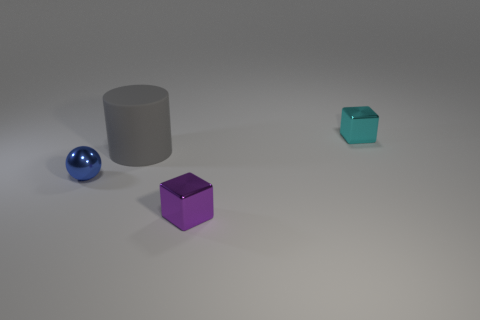How many things are things to the left of the tiny purple shiny object or tiny cubes that are in front of the tiny cyan metallic thing?
Provide a short and direct response. 3. Are there the same number of big objects in front of the big gray cylinder and small blue objects that are in front of the small blue sphere?
Give a very brief answer. Yes. There is a block that is to the left of the tiny cyan shiny block; what is its color?
Give a very brief answer. Purple. Does the shiny sphere have the same color as the shiny block that is in front of the tiny cyan metal object?
Your answer should be compact. No. Are there fewer big red blocks than blue metal balls?
Ensure brevity in your answer.  Yes. There is a small block that is to the right of the purple shiny object; is it the same color as the large matte cylinder?
Your response must be concise. No. What number of blue metallic spheres are the same size as the cyan block?
Your answer should be compact. 1. Is there another large cylinder of the same color as the big rubber cylinder?
Your answer should be very brief. No. Are the tiny blue object and the cylinder made of the same material?
Provide a short and direct response. No. What number of tiny blue objects have the same shape as the small cyan metallic thing?
Provide a short and direct response. 0. 